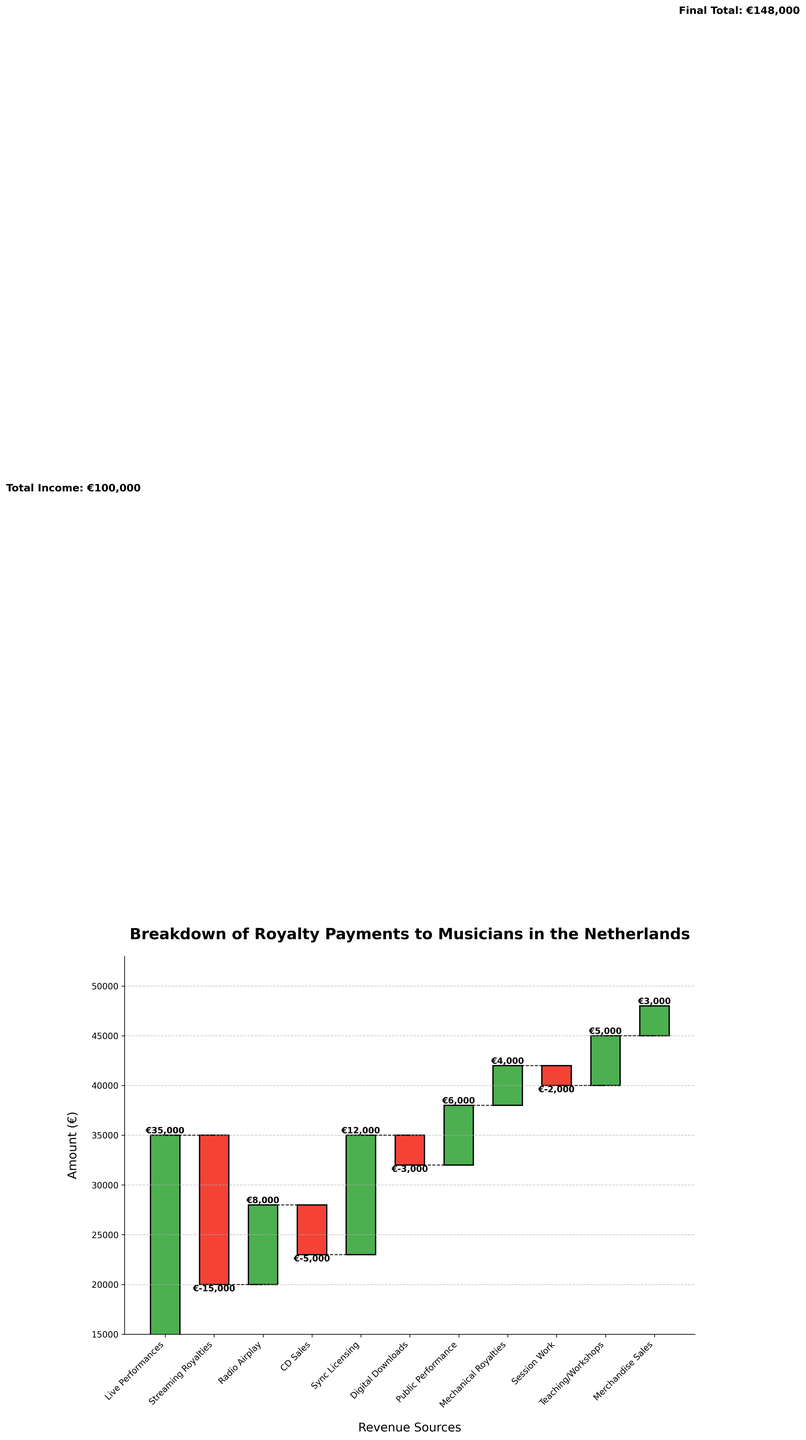What is the title of the figure? The title of the figure is displayed at the top center of the chart. It reads "Breakdown of Royalty Payments to Musicians in the Netherlands".
Answer: Breakdown of Royalty Payments to Musicians in the Netherlands What is the contribution from Live Performances? Locate the bar labeled "Live Performances" on the x-axis, then read the value displayed near the top of the corresponding bar.
Answer: €35,000 Which revenue source has the largest negative impact on the total income? Among the bars labeled with negative values (in red), identify the one with the largest absolute value.
Answer: Streaming Royalties What is the final total income? The final total income is displayed as text on the right side of the chart near the last bar.
Answer: €148,000 By how much do Streaming Royalties and CD Sales combined decrease the total income? Add the absolute values of Streaming Royalties (€15,000) and CD Sales (€5,000).
Answer: €20,000 Which revenue source has the highest positive contribution to the total income? Among the bars labeled with positive values (in green), identify the one with the largest absolute value.
Answer: Live Performances What is the net gain from Public Performance and Mechanical Royalties combined? Add the values of Public Performance (€6,000) and Mechanical Royalties (€4,000).
Answer: €10,000 How much do Teaching/Workshops and Merchandise Sales together add to the income? Add the values of Teaching/Workshops (€5,000) and Merchandise Sales (€3,000).
Answer: €8,000 Which revenue source is almost the same as the gain from Sync Licensing? Compare the values of other positive revenue sources to equal the value of Sync Licensing (€12,000). The closest is Live Performances, but Sync Licensing itself is unique.
Answer: None 